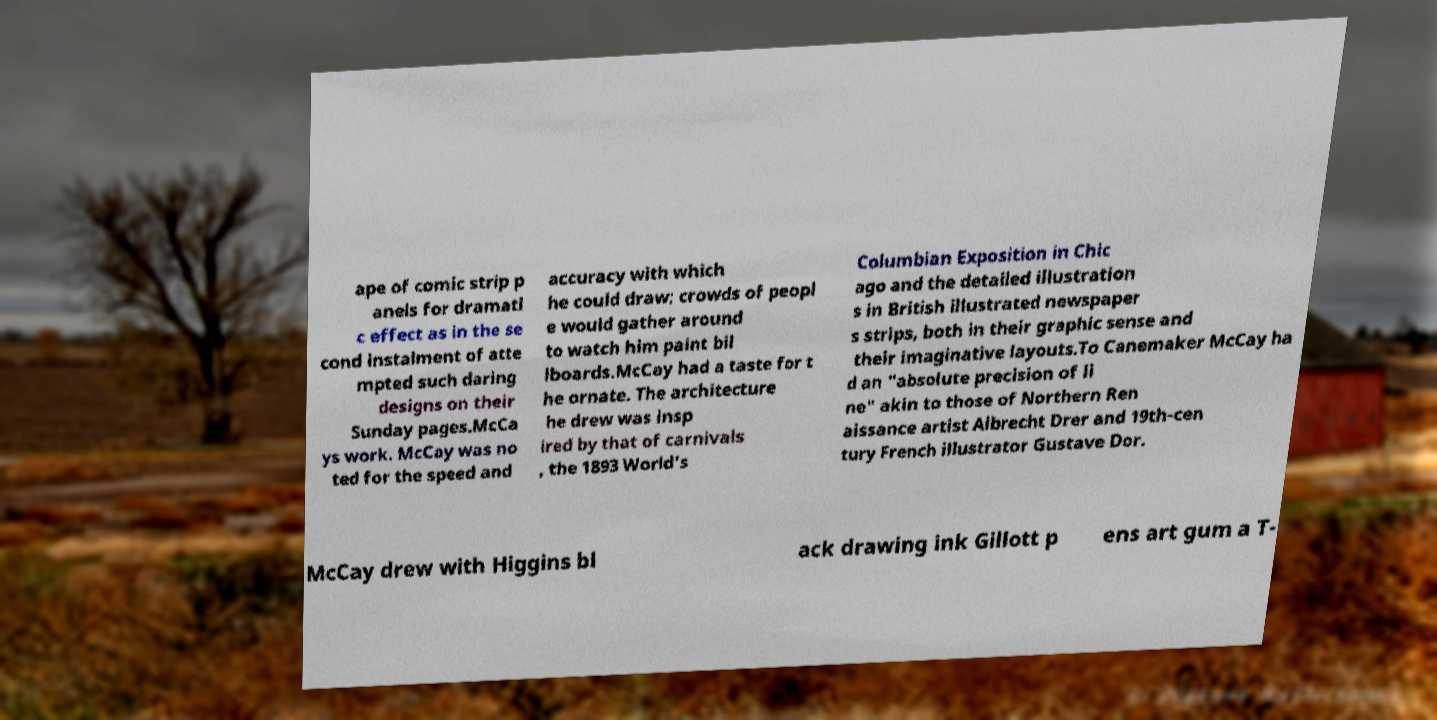There's text embedded in this image that I need extracted. Can you transcribe it verbatim? ape of comic strip p anels for dramati c effect as in the se cond instalment of atte mpted such daring designs on their Sunday pages.McCa ys work. McCay was no ted for the speed and accuracy with which he could draw; crowds of peopl e would gather around to watch him paint bil lboards.McCay had a taste for t he ornate. The architecture he drew was insp ired by that of carnivals , the 1893 World's Columbian Exposition in Chic ago and the detailed illustration s in British illustrated newspaper s strips, both in their graphic sense and their imaginative layouts.To Canemaker McCay ha d an "absolute precision of li ne" akin to those of Northern Ren aissance artist Albrecht Drer and 19th-cen tury French illustrator Gustave Dor. McCay drew with Higgins bl ack drawing ink Gillott p ens art gum a T- 